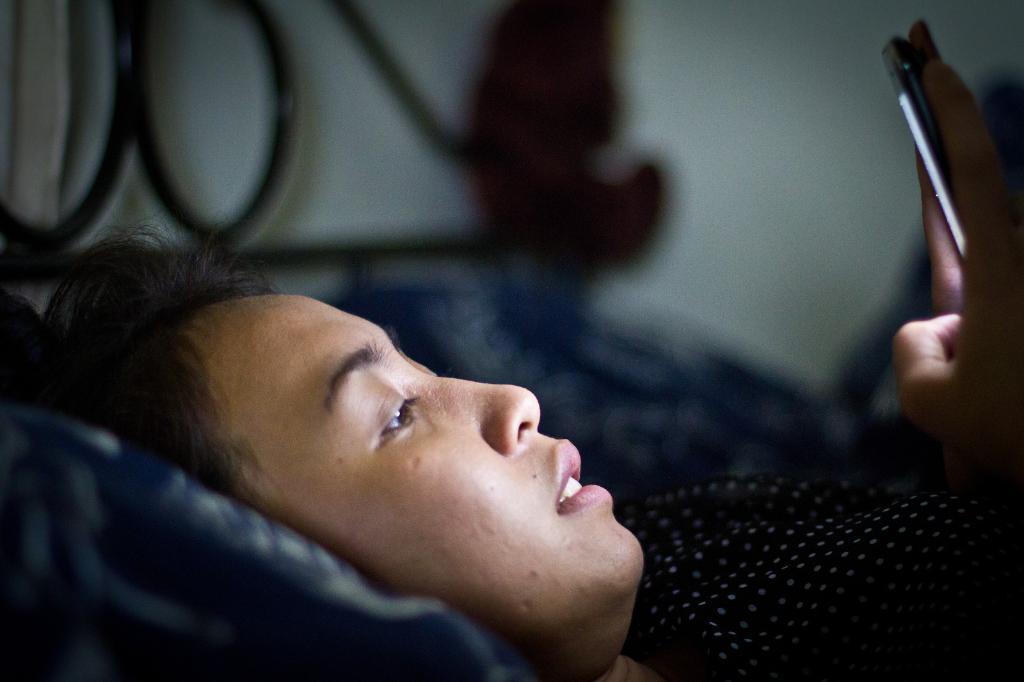Please provide a concise description of this image. In the center of the image a lady is lying on a bed and holding a mobile in her hand. At the top of the image wall is present. 